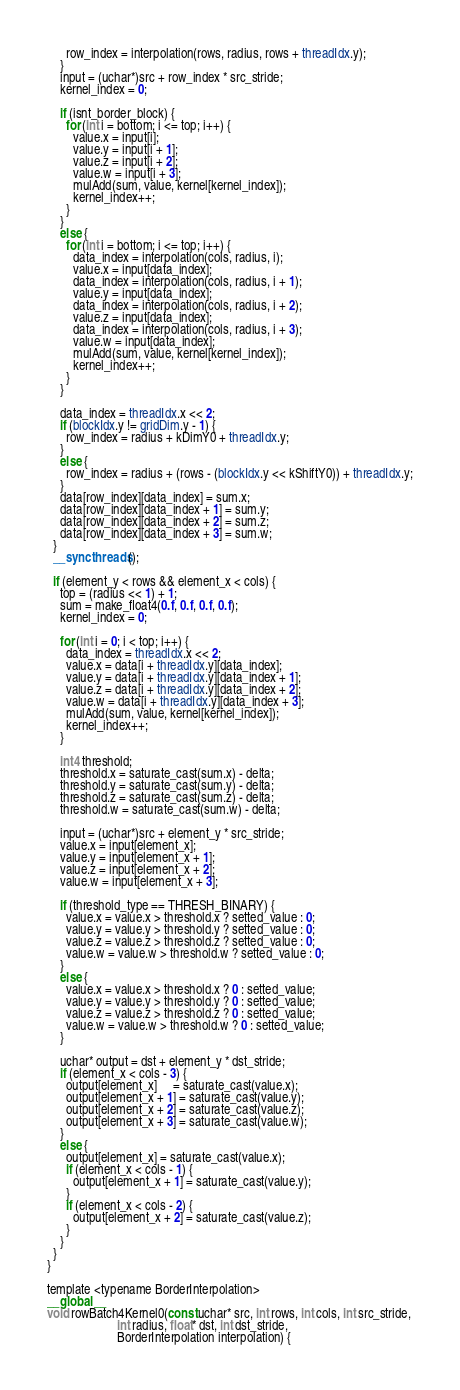<code> <loc_0><loc_0><loc_500><loc_500><_Cuda_>      row_index = interpolation(rows, radius, rows + threadIdx.y);
    }
    input = (uchar*)src + row_index * src_stride;
    kernel_index = 0;

    if (isnt_border_block) {
      for (int i = bottom; i <= top; i++) {
        value.x = input[i];
        value.y = input[i + 1];
        value.z = input[i + 2];
        value.w = input[i + 3];
        mulAdd(sum, value, kernel[kernel_index]);
        kernel_index++;
      }
    }
    else {
      for (int i = bottom; i <= top; i++) {
        data_index = interpolation(cols, radius, i);
        value.x = input[data_index];
        data_index = interpolation(cols, radius, i + 1);
        value.y = input[data_index];
        data_index = interpolation(cols, radius, i + 2);
        value.z = input[data_index];
        data_index = interpolation(cols, radius, i + 3);
        value.w = input[data_index];
        mulAdd(sum, value, kernel[kernel_index]);
        kernel_index++;
      }
    }

    data_index = threadIdx.x << 2;
    if (blockIdx.y != gridDim.y - 1) {
      row_index = radius + kDimY0 + threadIdx.y;
    }
    else {
      row_index = radius + (rows - (blockIdx.y << kShiftY0)) + threadIdx.y;
    }
    data[row_index][data_index] = sum.x;
    data[row_index][data_index + 1] = sum.y;
    data[row_index][data_index + 2] = sum.z;
    data[row_index][data_index + 3] = sum.w;
  }
  __syncthreads();

  if (element_y < rows && element_x < cols) {
    top = (radius << 1) + 1;
    sum = make_float4(0.f, 0.f, 0.f, 0.f);
    kernel_index = 0;

    for (int i = 0; i < top; i++) {
      data_index = threadIdx.x << 2;
      value.x = data[i + threadIdx.y][data_index];
      value.y = data[i + threadIdx.y][data_index + 1];
      value.z = data[i + threadIdx.y][data_index + 2];
      value.w = data[i + threadIdx.y][data_index + 3];
      mulAdd(sum, value, kernel[kernel_index]);
      kernel_index++;
    }

    int4 threshold;
    threshold.x = saturate_cast(sum.x) - delta;
    threshold.y = saturate_cast(sum.y) - delta;
    threshold.z = saturate_cast(sum.z) - delta;
    threshold.w = saturate_cast(sum.w) - delta;

    input = (uchar*)src + element_y * src_stride;
    value.x = input[element_x];
    value.y = input[element_x + 1];
    value.z = input[element_x + 2];
    value.w = input[element_x + 3];

    if (threshold_type == THRESH_BINARY) {
      value.x = value.x > threshold.x ? setted_value : 0;
      value.y = value.y > threshold.y ? setted_value : 0;
      value.z = value.z > threshold.z ? setted_value : 0;
      value.w = value.w > threshold.w ? setted_value : 0;
    }
    else {
      value.x = value.x > threshold.x ? 0 : setted_value;
      value.y = value.y > threshold.y ? 0 : setted_value;
      value.z = value.z > threshold.z ? 0 : setted_value;
      value.w = value.w > threshold.w ? 0 : setted_value;
    }

    uchar* output = dst + element_y * dst_stride;
    if (element_x < cols - 3) {
      output[element_x]     = saturate_cast(value.x);
      output[element_x + 1] = saturate_cast(value.y);
      output[element_x + 2] = saturate_cast(value.z);
      output[element_x + 3] = saturate_cast(value.w);
    }
    else {
      output[element_x] = saturate_cast(value.x);
      if (element_x < cols - 1) {
        output[element_x + 1] = saturate_cast(value.y);
      }
      if (element_x < cols - 2) {
        output[element_x + 2] = saturate_cast(value.z);
      }
    }
  }
}

template <typename BorderInterpolation>
__global__
void rowBatch4Kernel0(const uchar* src, int rows, int cols, int src_stride,
                      int radius, float* dst, int dst_stride,
                      BorderInterpolation interpolation) {</code> 